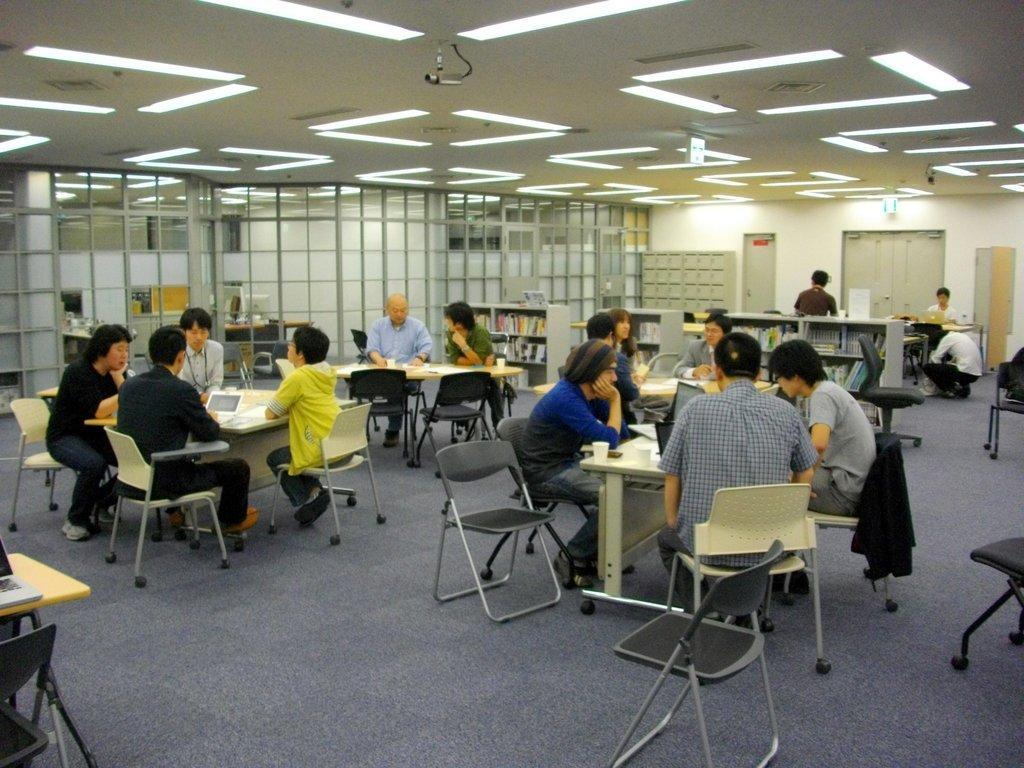Can you describe this image briefly? As we can see in the image there is a door, wall, chairs and tables and few people sitting on chairs. 